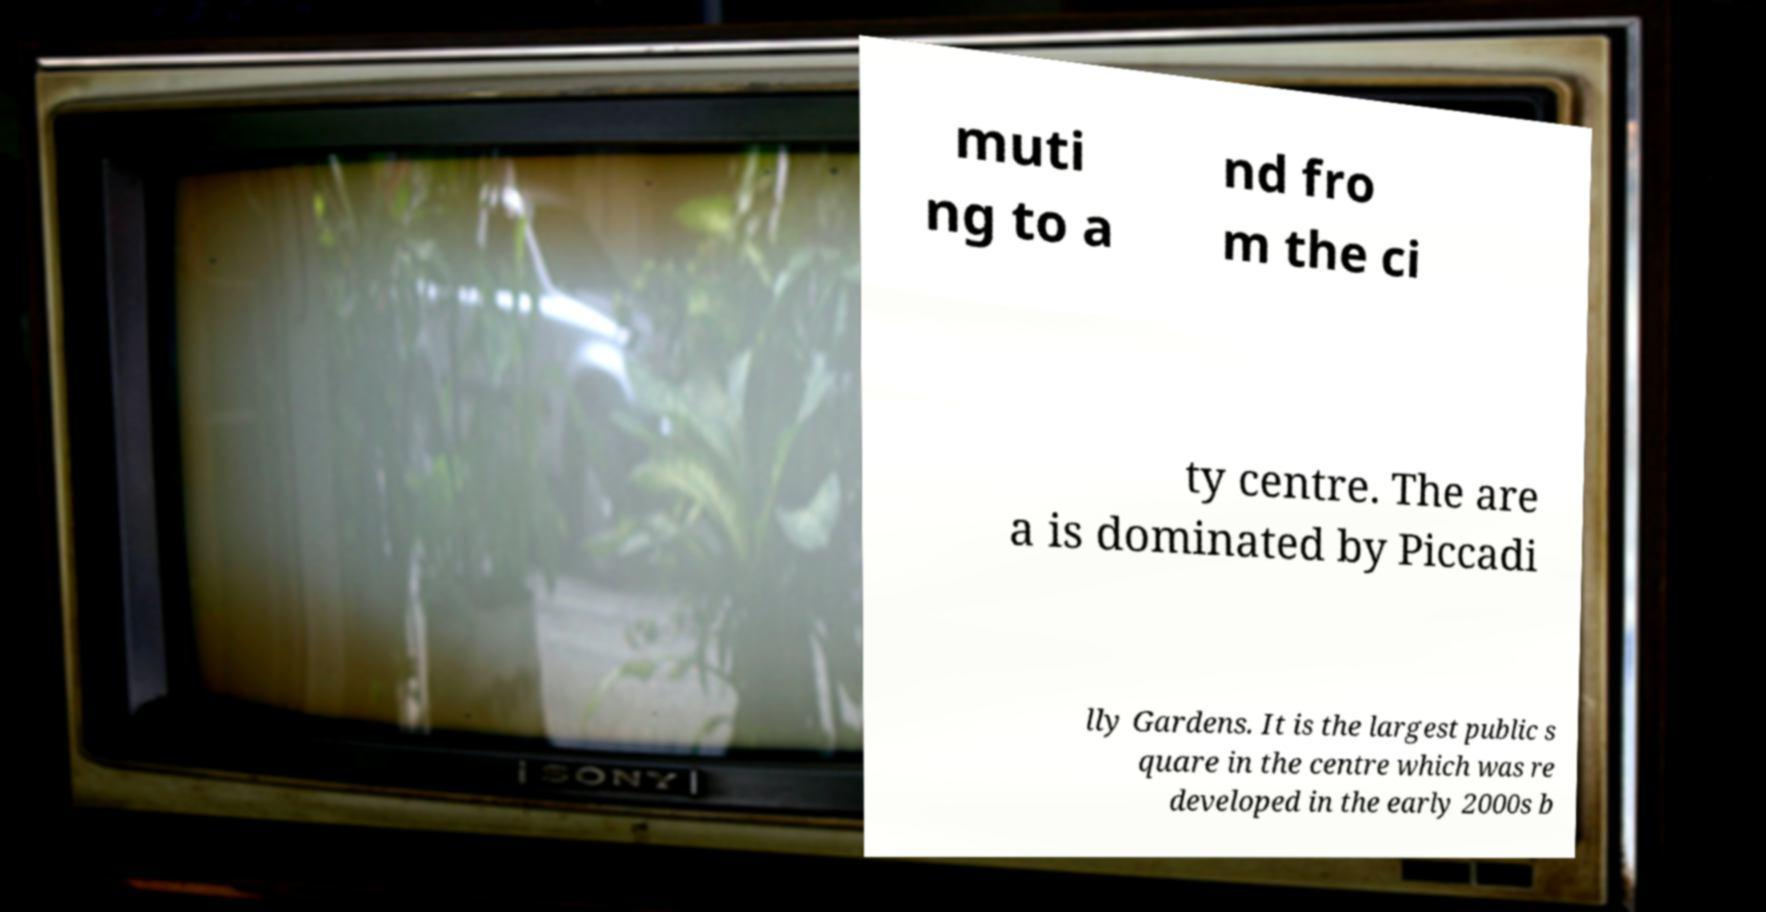Can you accurately transcribe the text from the provided image for me? muti ng to a nd fro m the ci ty centre. The are a is dominated by Piccadi lly Gardens. It is the largest public s quare in the centre which was re developed in the early 2000s b 